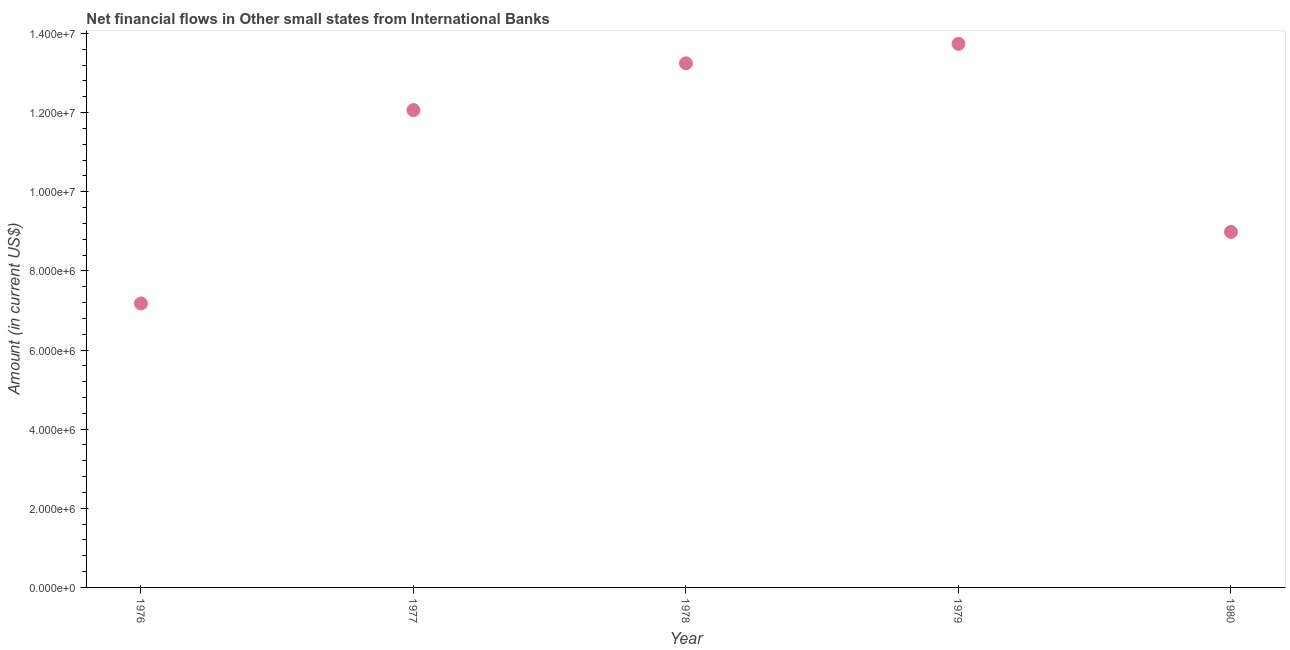What is the net financial flows from ibrd in 1980?
Your answer should be compact. 8.98e+06. Across all years, what is the maximum net financial flows from ibrd?
Offer a very short reply. 1.37e+07. Across all years, what is the minimum net financial flows from ibrd?
Keep it short and to the point. 7.18e+06. In which year was the net financial flows from ibrd maximum?
Provide a short and direct response. 1979. In which year was the net financial flows from ibrd minimum?
Offer a very short reply. 1976. What is the sum of the net financial flows from ibrd?
Your answer should be very brief. 5.52e+07. What is the difference between the net financial flows from ibrd in 1977 and 1979?
Keep it short and to the point. -1.68e+06. What is the average net financial flows from ibrd per year?
Provide a succinct answer. 1.10e+07. What is the median net financial flows from ibrd?
Your answer should be compact. 1.21e+07. In how many years, is the net financial flows from ibrd greater than 800000 US$?
Make the answer very short. 5. Do a majority of the years between 1978 and 1977 (inclusive) have net financial flows from ibrd greater than 6800000 US$?
Offer a very short reply. No. What is the ratio of the net financial flows from ibrd in 1979 to that in 1980?
Your answer should be compact. 1.53. What is the difference between the highest and the second highest net financial flows from ibrd?
Keep it short and to the point. 4.93e+05. Is the sum of the net financial flows from ibrd in 1978 and 1980 greater than the maximum net financial flows from ibrd across all years?
Make the answer very short. Yes. What is the difference between the highest and the lowest net financial flows from ibrd?
Your answer should be very brief. 6.56e+06. In how many years, is the net financial flows from ibrd greater than the average net financial flows from ibrd taken over all years?
Your response must be concise. 3. Does the net financial flows from ibrd monotonically increase over the years?
Ensure brevity in your answer.  No. How many years are there in the graph?
Keep it short and to the point. 5. Does the graph contain any zero values?
Make the answer very short. No. What is the title of the graph?
Your answer should be compact. Net financial flows in Other small states from International Banks. What is the label or title of the X-axis?
Your response must be concise. Year. What is the Amount (in current US$) in 1976?
Ensure brevity in your answer.  7.18e+06. What is the Amount (in current US$) in 1977?
Your response must be concise. 1.21e+07. What is the Amount (in current US$) in 1978?
Make the answer very short. 1.32e+07. What is the Amount (in current US$) in 1979?
Provide a short and direct response. 1.37e+07. What is the Amount (in current US$) in 1980?
Keep it short and to the point. 8.98e+06. What is the difference between the Amount (in current US$) in 1976 and 1977?
Give a very brief answer. -4.89e+06. What is the difference between the Amount (in current US$) in 1976 and 1978?
Make the answer very short. -6.07e+06. What is the difference between the Amount (in current US$) in 1976 and 1979?
Provide a short and direct response. -6.56e+06. What is the difference between the Amount (in current US$) in 1976 and 1980?
Offer a very short reply. -1.81e+06. What is the difference between the Amount (in current US$) in 1977 and 1978?
Offer a very short reply. -1.18e+06. What is the difference between the Amount (in current US$) in 1977 and 1979?
Offer a very short reply. -1.68e+06. What is the difference between the Amount (in current US$) in 1977 and 1980?
Keep it short and to the point. 3.08e+06. What is the difference between the Amount (in current US$) in 1978 and 1979?
Your answer should be very brief. -4.93e+05. What is the difference between the Amount (in current US$) in 1978 and 1980?
Your response must be concise. 4.26e+06. What is the difference between the Amount (in current US$) in 1979 and 1980?
Make the answer very short. 4.76e+06. What is the ratio of the Amount (in current US$) in 1976 to that in 1977?
Your answer should be very brief. 0.59. What is the ratio of the Amount (in current US$) in 1976 to that in 1978?
Provide a short and direct response. 0.54. What is the ratio of the Amount (in current US$) in 1976 to that in 1979?
Provide a short and direct response. 0.52. What is the ratio of the Amount (in current US$) in 1976 to that in 1980?
Provide a short and direct response. 0.8. What is the ratio of the Amount (in current US$) in 1977 to that in 1978?
Your answer should be very brief. 0.91. What is the ratio of the Amount (in current US$) in 1977 to that in 1979?
Offer a terse response. 0.88. What is the ratio of the Amount (in current US$) in 1977 to that in 1980?
Your response must be concise. 1.34. What is the ratio of the Amount (in current US$) in 1978 to that in 1979?
Offer a very short reply. 0.96. What is the ratio of the Amount (in current US$) in 1978 to that in 1980?
Give a very brief answer. 1.47. What is the ratio of the Amount (in current US$) in 1979 to that in 1980?
Ensure brevity in your answer.  1.53. 